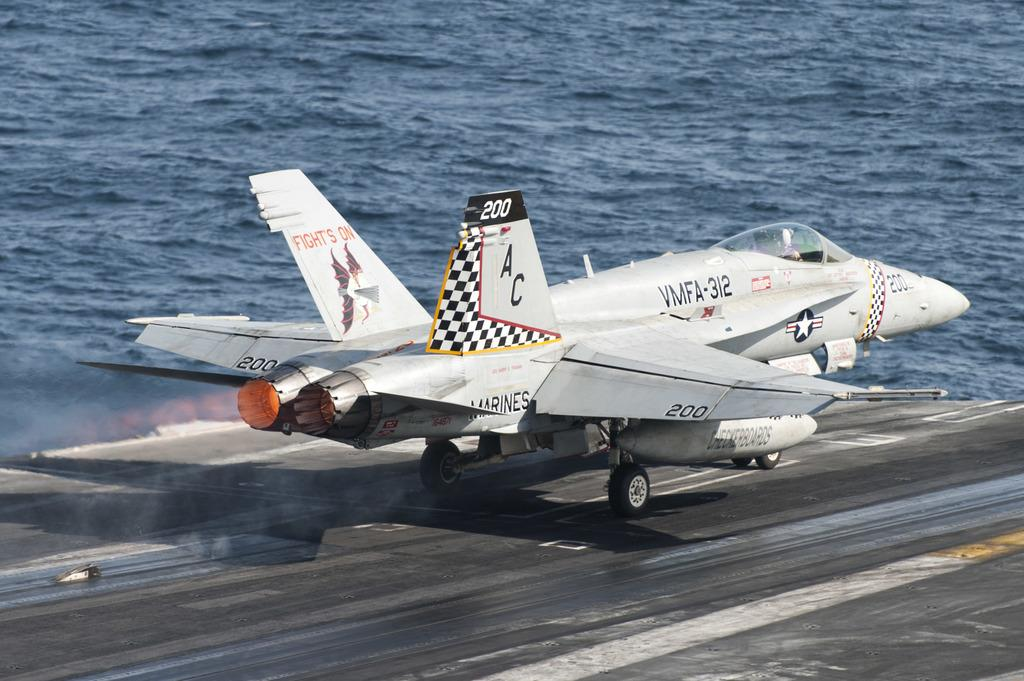<image>
Present a compact description of the photo's key features. A plane that belongs to the Marines and has the number 200 on it gets ready for takeoff. 